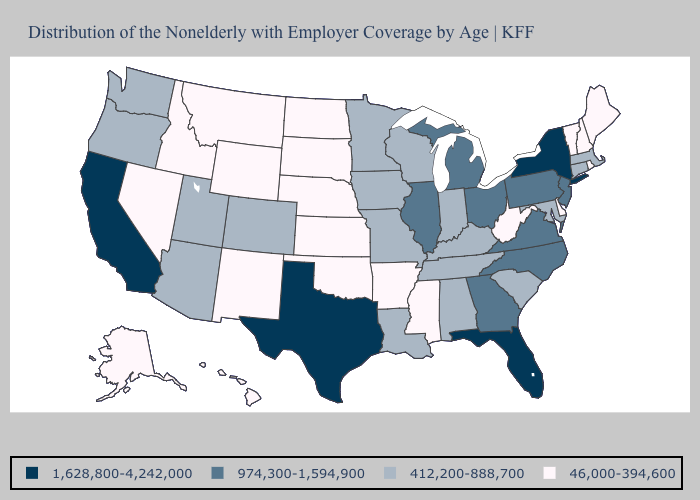Name the states that have a value in the range 974,300-1,594,900?
Write a very short answer. Georgia, Illinois, Michigan, New Jersey, North Carolina, Ohio, Pennsylvania, Virginia. What is the highest value in the USA?
Give a very brief answer. 1,628,800-4,242,000. What is the value of Wisconsin?
Quick response, please. 412,200-888,700. How many symbols are there in the legend?
Concise answer only. 4. Does Indiana have the lowest value in the USA?
Short answer required. No. Among the states that border Ohio , which have the highest value?
Concise answer only. Michigan, Pennsylvania. Which states have the lowest value in the USA?
Answer briefly. Alaska, Arkansas, Delaware, Hawaii, Idaho, Kansas, Maine, Mississippi, Montana, Nebraska, Nevada, New Hampshire, New Mexico, North Dakota, Oklahoma, Rhode Island, South Dakota, Vermont, West Virginia, Wyoming. What is the highest value in the USA?
Answer briefly. 1,628,800-4,242,000. What is the value of New Jersey?
Write a very short answer. 974,300-1,594,900. What is the lowest value in the USA?
Write a very short answer. 46,000-394,600. What is the value of North Dakota?
Write a very short answer. 46,000-394,600. Which states have the lowest value in the USA?
Keep it brief. Alaska, Arkansas, Delaware, Hawaii, Idaho, Kansas, Maine, Mississippi, Montana, Nebraska, Nevada, New Hampshire, New Mexico, North Dakota, Oklahoma, Rhode Island, South Dakota, Vermont, West Virginia, Wyoming. Does the first symbol in the legend represent the smallest category?
Quick response, please. No. Name the states that have a value in the range 46,000-394,600?
Short answer required. Alaska, Arkansas, Delaware, Hawaii, Idaho, Kansas, Maine, Mississippi, Montana, Nebraska, Nevada, New Hampshire, New Mexico, North Dakota, Oklahoma, Rhode Island, South Dakota, Vermont, West Virginia, Wyoming. Does Mississippi have the lowest value in the South?
Be succinct. Yes. 